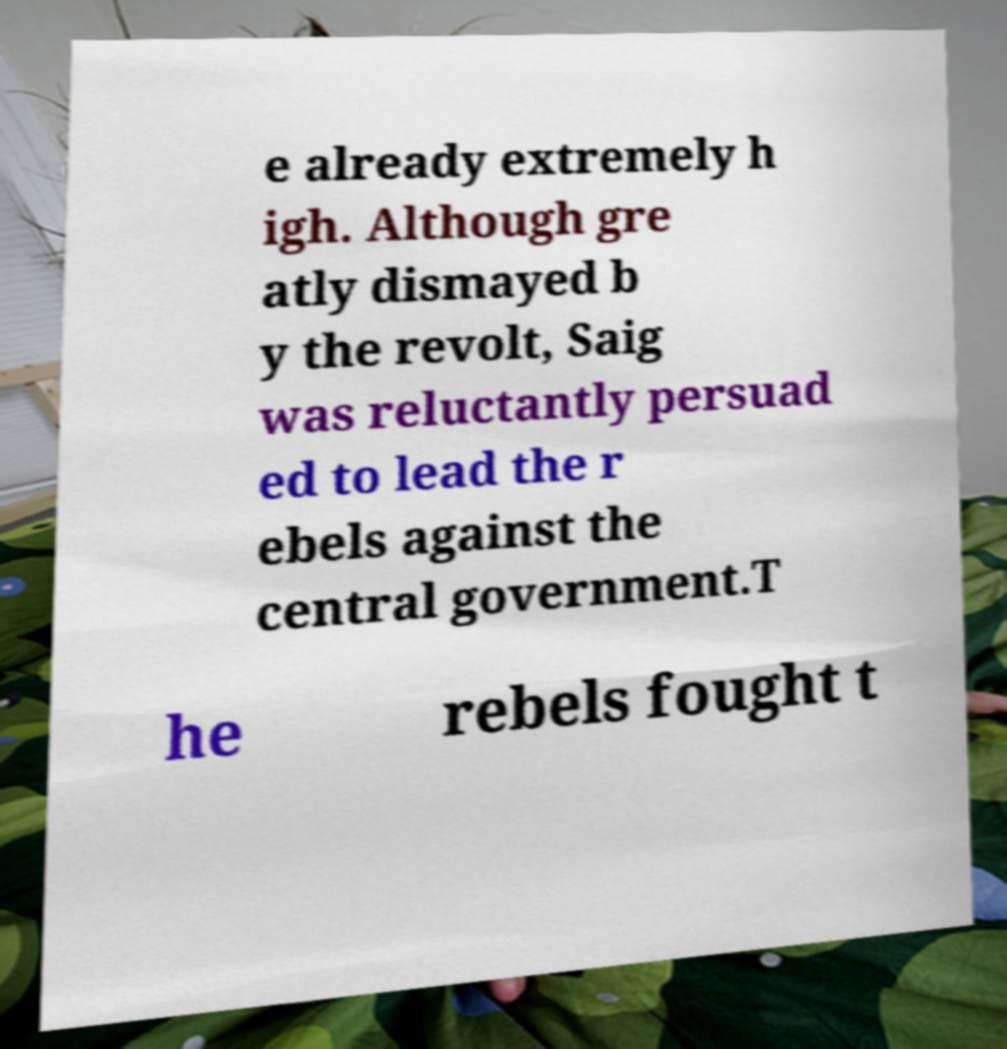What messages or text are displayed in this image? I need them in a readable, typed format. e already extremely h igh. Although gre atly dismayed b y the revolt, Saig was reluctantly persuad ed to lead the r ebels against the central government.T he rebels fought t 